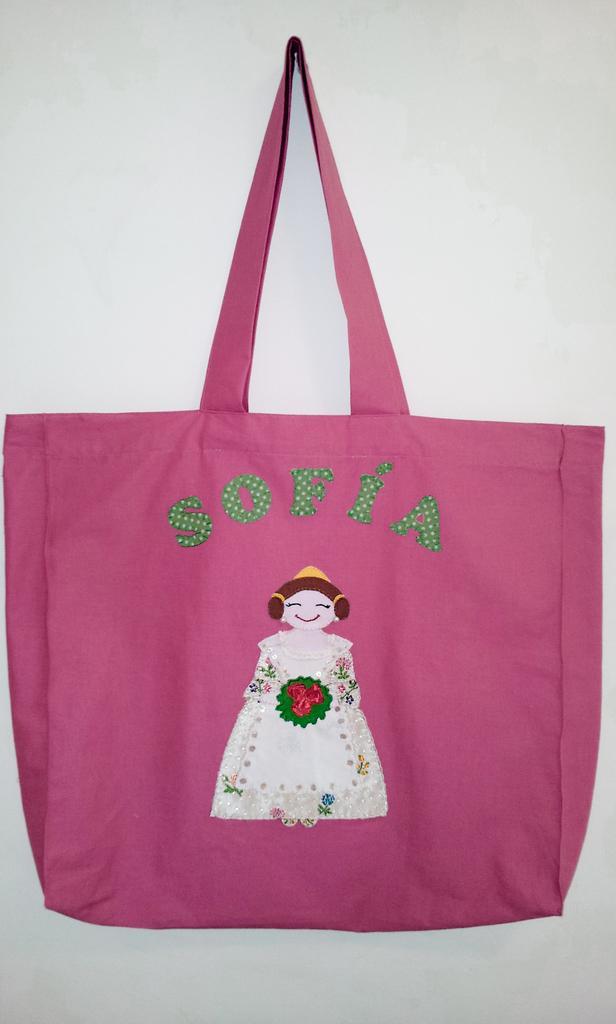Please provide a concise description of this image. In this picture we can a see a pink color cloth bag with a woman holding flowers in her hand painting on it. 